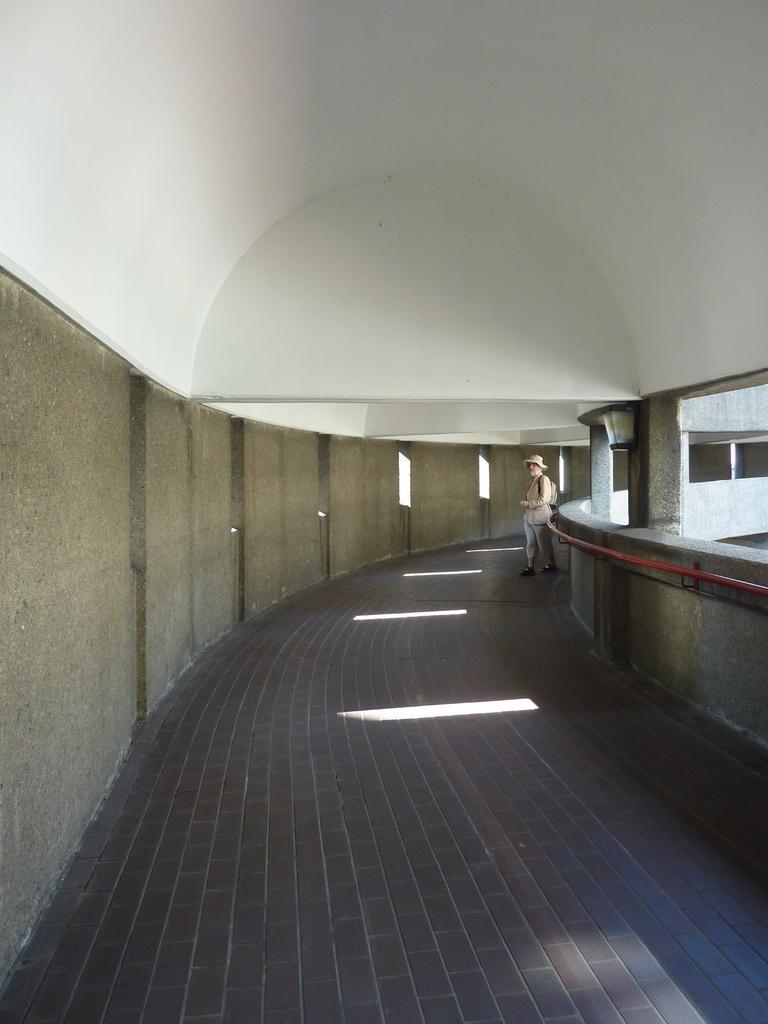Can you describe this image briefly? In this picture I can see a person standing inside a building , there is a iron rod and pillars. 